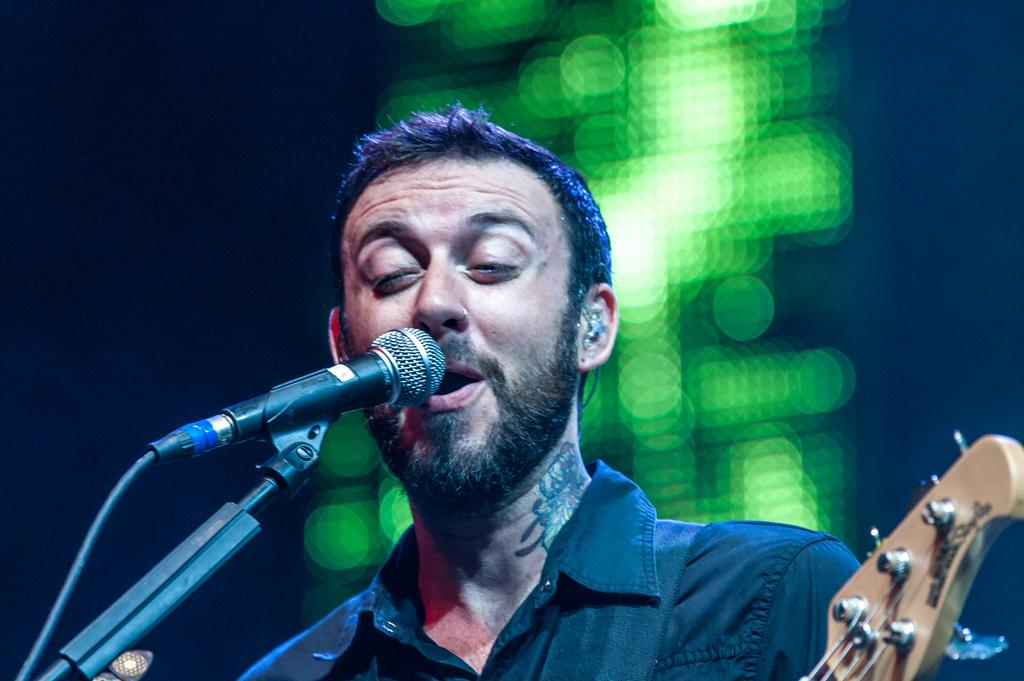What is the main subject of the image? The main subject of the image is a man. What is the man doing in the image? The man is singing a song in the image. What tool is the man using to amplify his voice? The man is using a microphone in the image. What is the man holding in his hands? The man is holding a musical instrument in the image. What is the purpose of the microphone stand in the image? The microphone stand is used to hold the microphone in place for the man to use while singing. What type of stone can be seen being used as a spade in the image? There is no stone or spade present in the image; it features a man singing with a microphone and holding a musical instrument. 